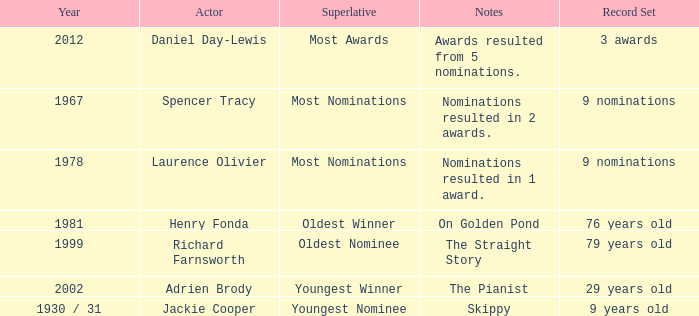What year did actor Richard Farnsworth get nominated for an award? 1999.0. 